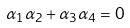Convert formula to latex. <formula><loc_0><loc_0><loc_500><loc_500>\alpha _ { 1 } \alpha _ { 2 } + \alpha _ { 3 } \alpha _ { 4 } = 0</formula> 